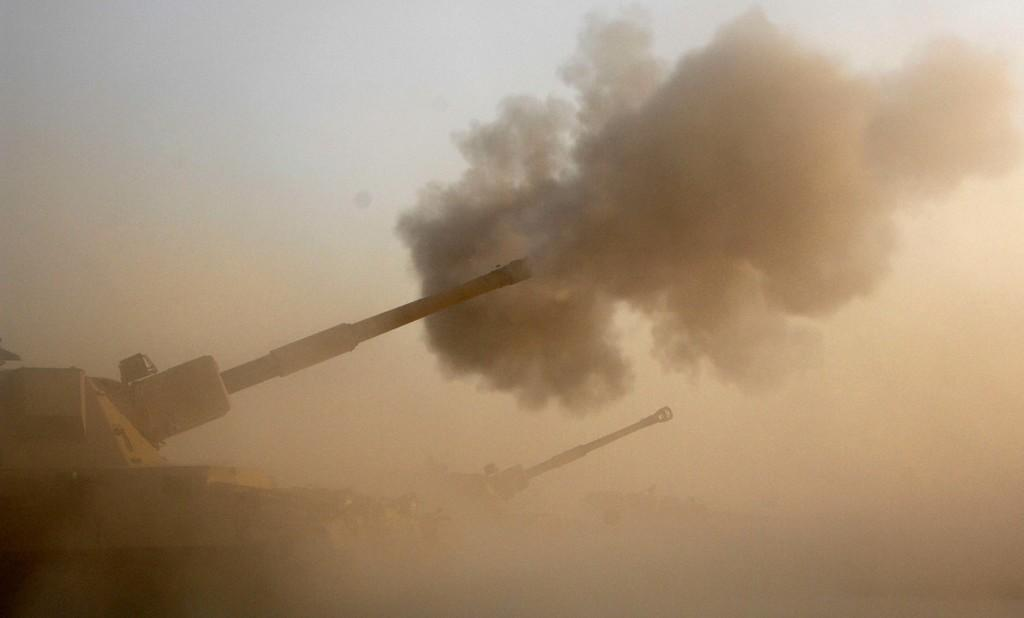What type of vehicles are present in the image? There are military tanks in the image. What else can be seen in the image besides the tanks? There is smoke visible in the image. What part of the natural environment is visible in the image? The sky is visible in the image. What type of cork can be seen floating in the sky in the image? There is no cork present in the image; the sky is visible, but it does not contain any cork. 